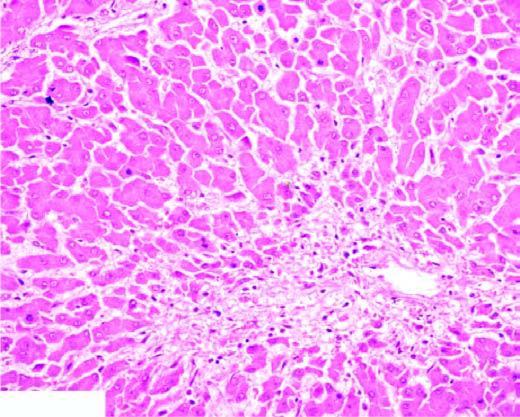does the pink acellular amyloid material show mild fatty change of liver cells?
Answer the question using a single word or phrase. No 